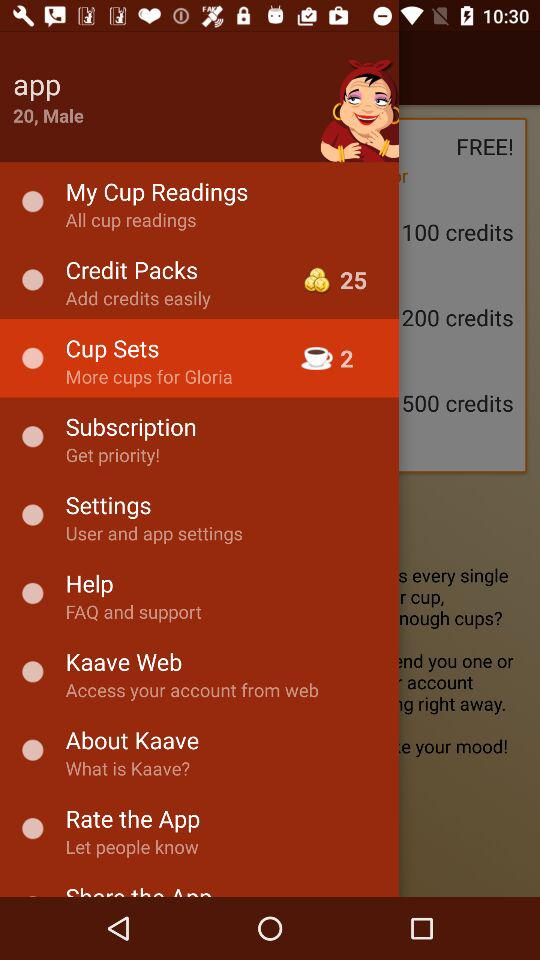What is the user name? The user name is App. 